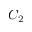Convert formula to latex. <formula><loc_0><loc_0><loc_500><loc_500>C _ { 2 }</formula> 